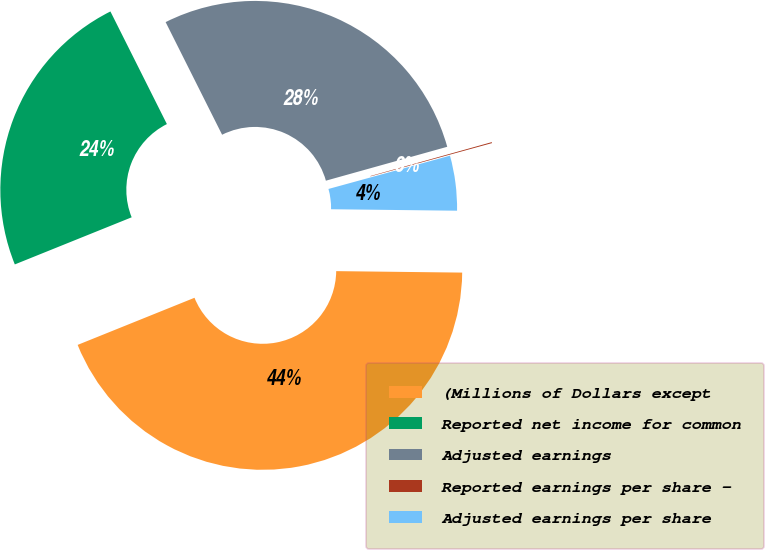Convert chart. <chart><loc_0><loc_0><loc_500><loc_500><pie_chart><fcel>(Millions of Dollars except<fcel>Reported net income for common<fcel>Adjusted earnings<fcel>Reported earnings per share -<fcel>Adjusted earnings per share<nl><fcel>43.71%<fcel>23.7%<fcel>28.06%<fcel>0.08%<fcel>4.44%<nl></chart> 